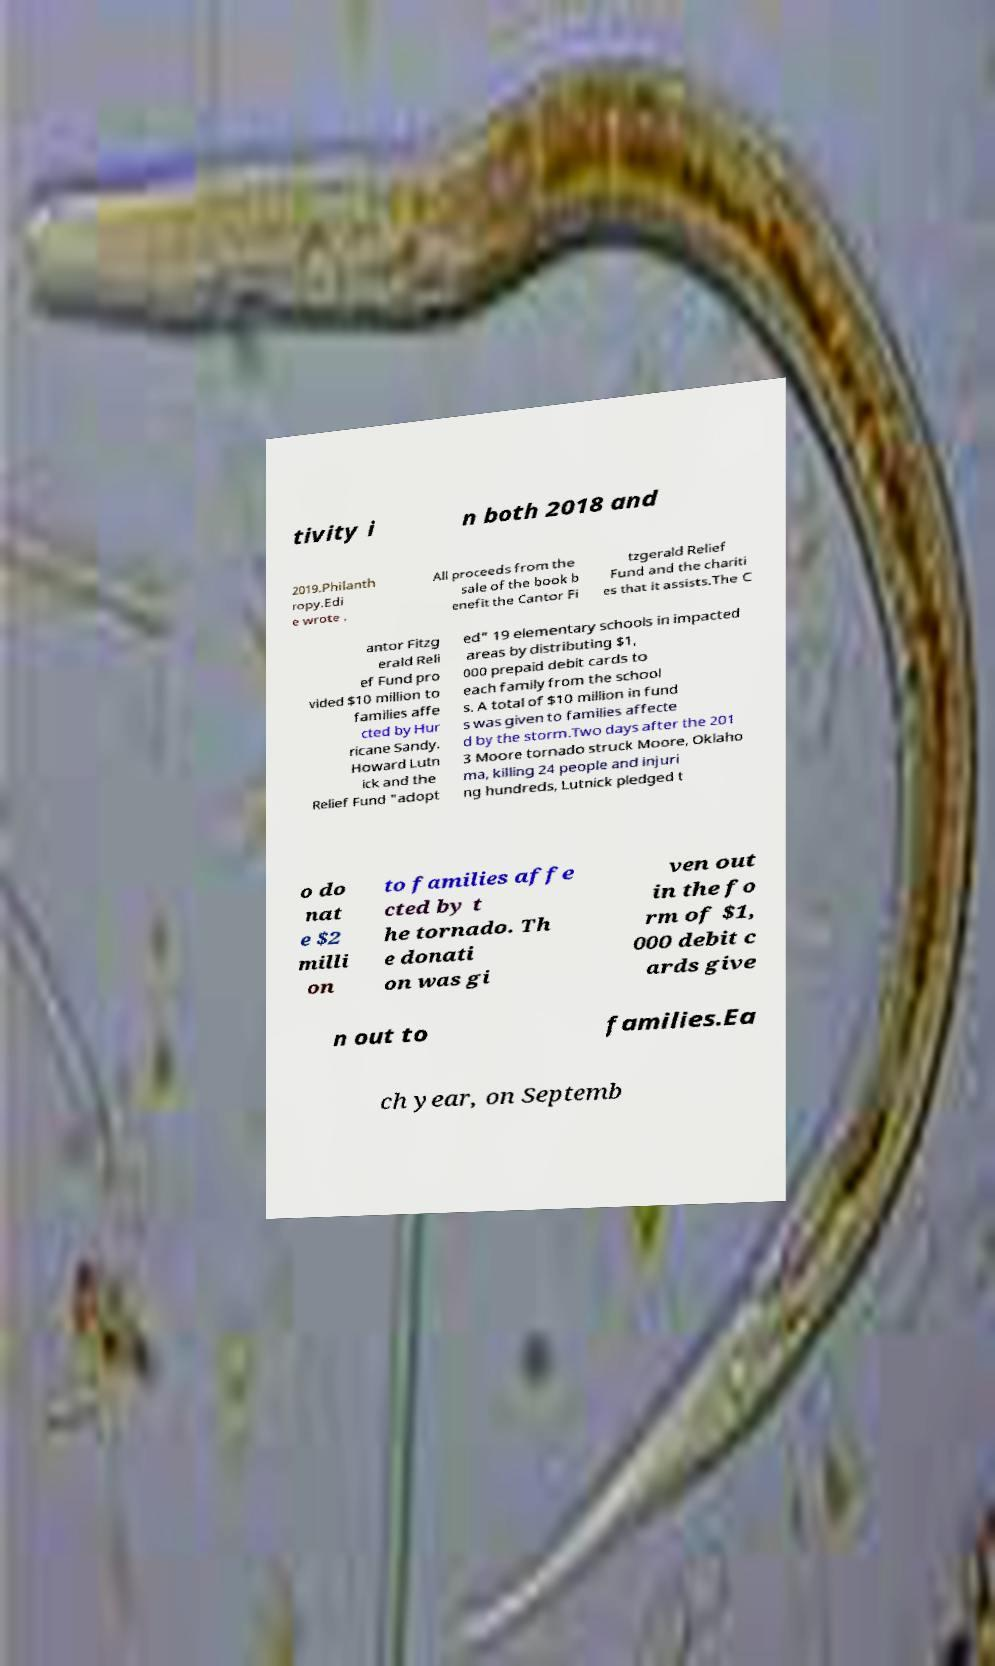What messages or text are displayed in this image? I need them in a readable, typed format. tivity i n both 2018 and 2019.Philanth ropy.Edi e wrote . All proceeds from the sale of the book b enefit the Cantor Fi tzgerald Relief Fund and the chariti es that it assists.The C antor Fitzg erald Reli ef Fund pro vided $10 million to families affe cted by Hur ricane Sandy. Howard Lutn ick and the Relief Fund "adopt ed" 19 elementary schools in impacted areas by distributing $1, 000 prepaid debit cards to each family from the school s. A total of $10 million in fund s was given to families affecte d by the storm.Two days after the 201 3 Moore tornado struck Moore, Oklaho ma, killing 24 people and injuri ng hundreds, Lutnick pledged t o do nat e $2 milli on to families affe cted by t he tornado. Th e donati on was gi ven out in the fo rm of $1, 000 debit c ards give n out to families.Ea ch year, on Septemb 